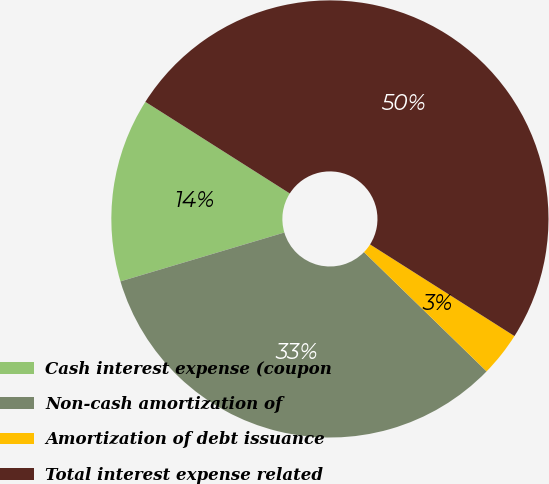Convert chart to OTSL. <chart><loc_0><loc_0><loc_500><loc_500><pie_chart><fcel>Cash interest expense (coupon<fcel>Non-cash amortization of<fcel>Amortization of debt issuance<fcel>Total interest expense related<nl><fcel>13.61%<fcel>33.11%<fcel>3.28%<fcel>50.0%<nl></chart> 